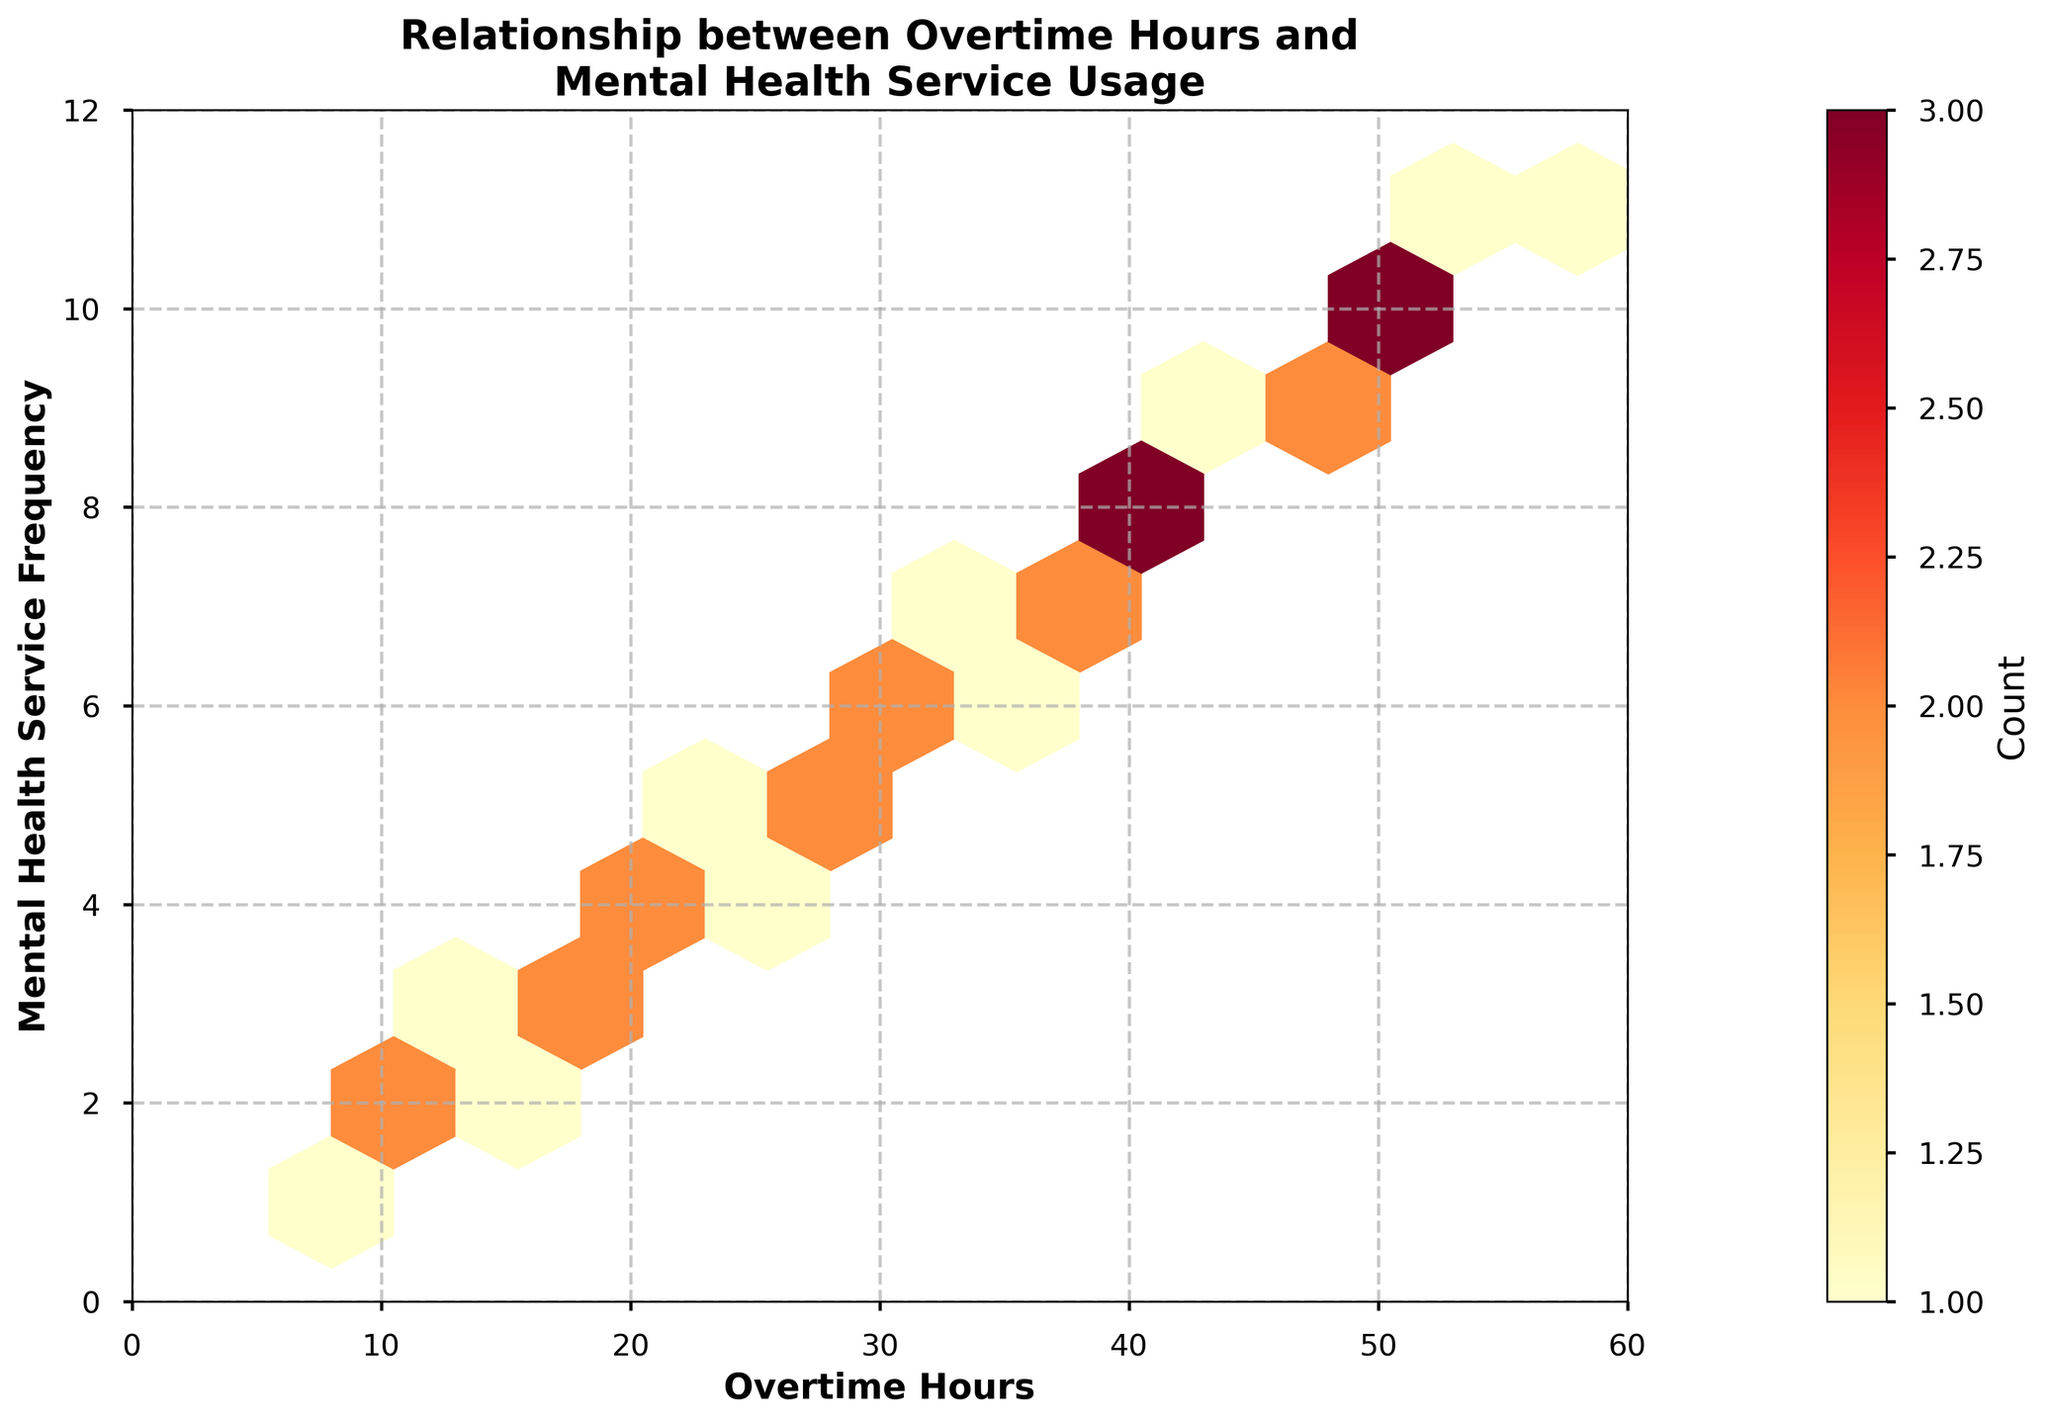what is the title of the figure? The title of the figure is usually located at the top center and summarizes the topic of the plot.
Answer: Relationship between Overtime Hours and Mental Health Service Usage What do the X and Y axes represent? The X axis represents "Overtime Hours" and the Y axis represents "Mental Health Service Frequency." The labels are visible on the axes themselves.
Answer: Overtime Hours and Mental Health Service Frequency What color represents the highest density or count in the hexbin plot? The color scheme used in the hexbin plot indicates density; typically, in a YlOrRd colormap, the color closest to red represents the highest density.
Answer: Red What is the range of the X axis in the hexbin plot? The X axis range can be determined by observing the minimum and maximum values on the axis. From the plot, it spans from 0 to 60 overtime hours.
Answer: 0 to 60 What is the range of the Y axis? The Y axis range can be determined by observing the minimum and maximum values on the axis. From the plot, it spans from 0 to 12 mental health service frequency.
Answer: 0 to 12 Where are the highest number of overlapping data points located? The highest number of overlapping data points are represented by the darkest hexagons. By looking at the plot, these are found in the middle region where the color is most intense around 30-40 overtime hours and 6-8 mental health service frequency.
Answer: 30-40 overtime hours and 6-8 mental health service frequency What is the overall trend between overtime hours and mental health service frequency? By observing the hexbin plot, one can see an upward trend where more overtime hours correspond to higher mental health service frequency.
Answer: Upward trend Which hexagonal bins are located at the extremes of both axes? The extremes of the axes are found at the top-right and bottom-left corners of the plot. By observing, the top-right has bins near 60 overtime hours and 12 mental health services, and bottom-left near 0 and 0.
Answer: Top-right (60, 12) and Bottom-left (0, 0) Is there any region with zero count hexagonal bins in the hexbin plot? These regions can be identified by light-colored or nearly white hexagons. Observing the plot, regions outside the main cluster, especially far corners, have low or zero count.
Answer: Yes, particularly in the far corners Comparing the frequency of accessing mental health services, do employees working 50 hours of overtime show more service usage than those working 10 hours? Observing the hexbin plot, one can see that the frequency is higher around 50 hours relative to 10 hours as indicated by the density and color intensity.
Answer: Yes 